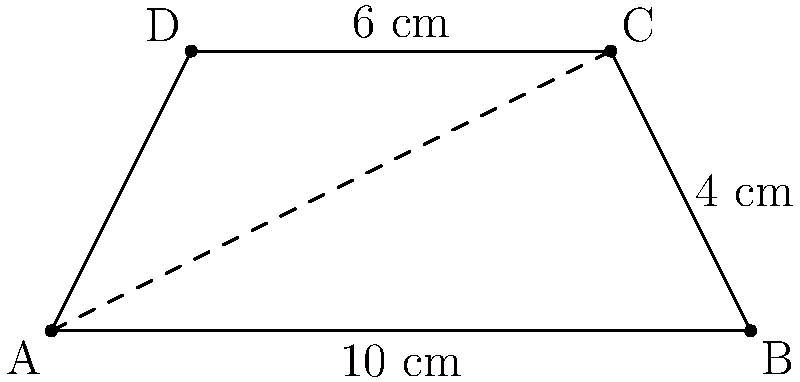A trapezoid ABCD has parallel sides of lengths 10 cm and 6 cm. The height of the trapezoid is 4 cm. Calculate the perimeter and area of the trapezoid. Round your answers to the nearest hundredth if necessary. To solve this problem, we'll calculate the perimeter and area separately:

1. Perimeter calculation:
   a) We know the lengths of the parallel sides: AB = 10 cm and DC = 6 cm
   b) To find the length of BC and AD, we can use the Pythagorean theorem:
      $BC^2 = 4^2 + 2^2 = 16 + 4 = 20$
      $BC = \sqrt{20} = 2\sqrt{5} \approx 4.47$ cm
   c) AD will have the same length as BC
   d) Perimeter = AB + BC + CD + DA
                = $10 + 2\sqrt{5} + 6 + 2\sqrt{5}$
                = $16 + 4\sqrt{5} \approx 24.94$ cm

2. Area calculation:
   The area of a trapezoid is given by the formula:
   $A = \frac{1}{2}(a+b)h$, where a and b are the parallel sides and h is the height
   
   $A = \frac{1}{2}(10+6) \times 4$
   $A = \frac{1}{2} \times 16 \times 4$
   $A = 32$ sq cm

Therefore, the perimeter is approximately 24.94 cm, and the area is 32 sq cm.
Answer: Perimeter: 24.94 cm, Area: 32 sq cm 